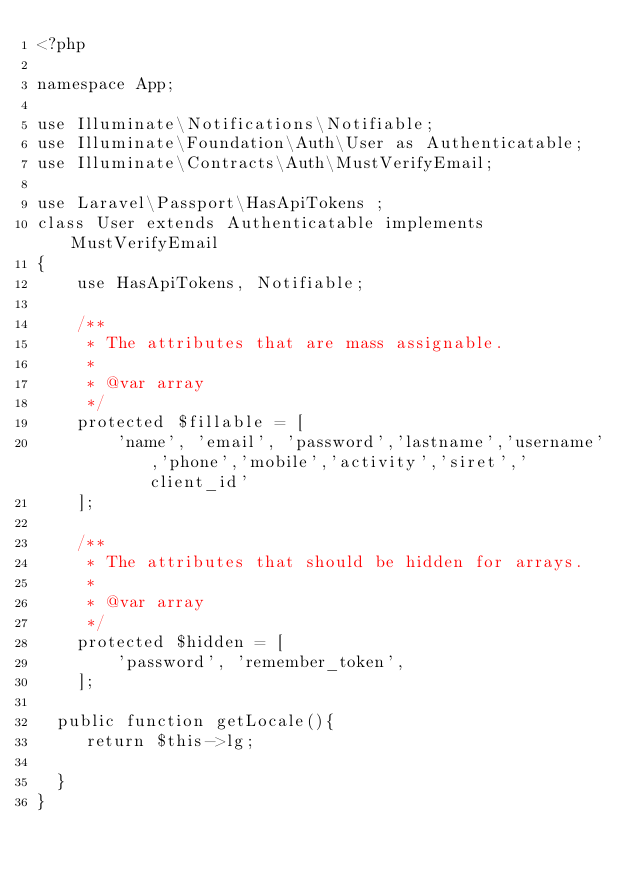Convert code to text. <code><loc_0><loc_0><loc_500><loc_500><_PHP_><?php

namespace App;

use Illuminate\Notifications\Notifiable;
use Illuminate\Foundation\Auth\User as Authenticatable;
use Illuminate\Contracts\Auth\MustVerifyEmail;

use Laravel\Passport\HasApiTokens ;
class User extends Authenticatable implements MustVerifyEmail
{
    use HasApiTokens, Notifiable;

    /**
     * The attributes that are mass assignable.
     *
     * @var array
     */
    protected $fillable = [
        'name', 'email', 'password','lastname','username','phone','mobile','activity','siret','client_id'
    ];

    /**
     * The attributes that should be hidden for arrays.
     *
     * @var array
     */
    protected $hidden = [
        'password', 'remember_token',
    ];
	
	public function getLocale(){
 		 return $this->lg;

	}
}
</code> 